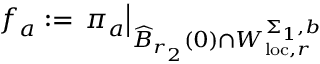Convert formula to latex. <formula><loc_0><loc_0><loc_500><loc_500>f _ { a } \colon = \pi _ { a } \right | _ { \widehat { B } _ { r _ { 2 } } ( 0 ) \cap W _ { l o c , r } ^ { \Sigma _ { 1 } , b } }</formula> 